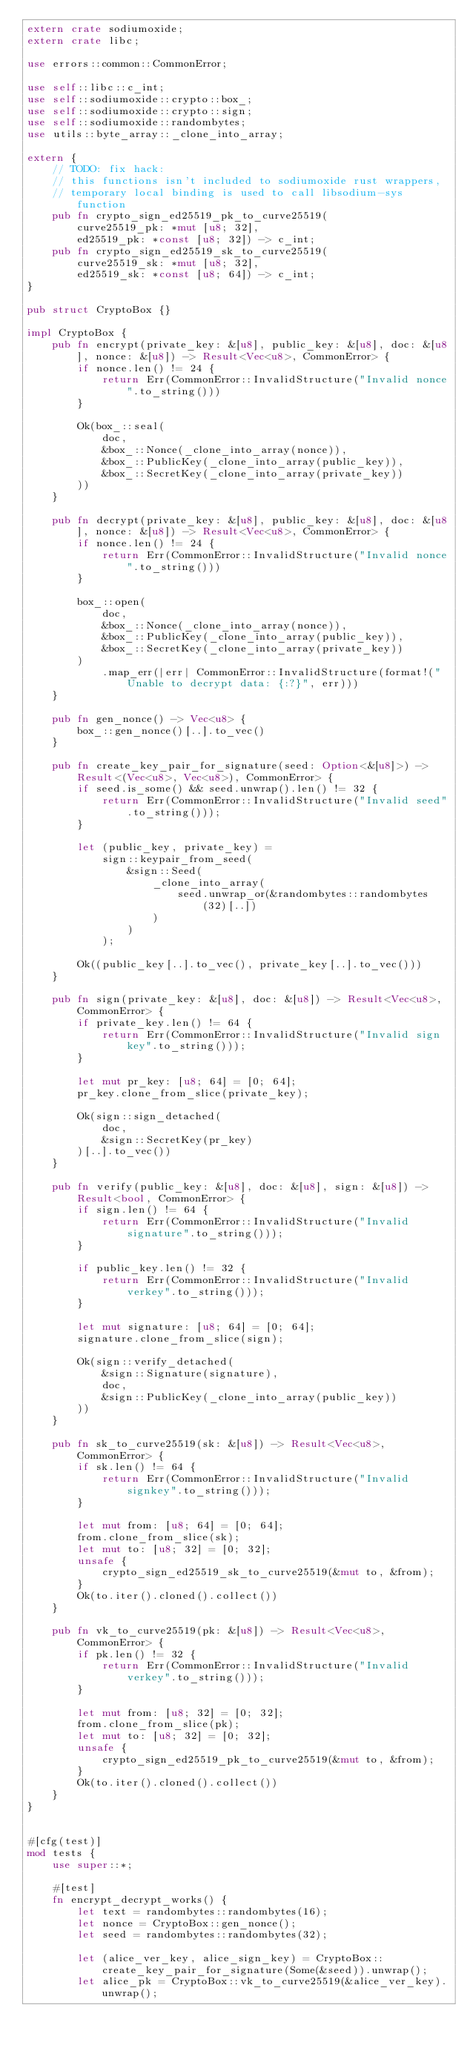<code> <loc_0><loc_0><loc_500><loc_500><_Rust_>extern crate sodiumoxide;
extern crate libc;

use errors::common::CommonError;

use self::libc::c_int;
use self::sodiumoxide::crypto::box_;
use self::sodiumoxide::crypto::sign;
use self::sodiumoxide::randombytes;
use utils::byte_array::_clone_into_array;

extern {
    // TODO: fix hack:
    // this functions isn't included to sodiumoxide rust wrappers,
    // temporary local binding is used to call libsodium-sys function
    pub fn crypto_sign_ed25519_pk_to_curve25519(
        curve25519_pk: *mut [u8; 32],
        ed25519_pk: *const [u8; 32]) -> c_int;
    pub fn crypto_sign_ed25519_sk_to_curve25519(
        curve25519_sk: *mut [u8; 32],
        ed25519_sk: *const [u8; 64]) -> c_int;
}

pub struct CryptoBox {}

impl CryptoBox {
    pub fn encrypt(private_key: &[u8], public_key: &[u8], doc: &[u8], nonce: &[u8]) -> Result<Vec<u8>, CommonError> {
        if nonce.len() != 24 {
            return Err(CommonError::InvalidStructure("Invalid nonce".to_string()))
        }

        Ok(box_::seal(
            doc,
            &box_::Nonce(_clone_into_array(nonce)),
            &box_::PublicKey(_clone_into_array(public_key)),
            &box_::SecretKey(_clone_into_array(private_key))
        ))
    }

    pub fn decrypt(private_key: &[u8], public_key: &[u8], doc: &[u8], nonce: &[u8]) -> Result<Vec<u8>, CommonError> {
        if nonce.len() != 24 {
            return Err(CommonError::InvalidStructure("Invalid nonce".to_string()))
        }

        box_::open(
            doc,
            &box_::Nonce(_clone_into_array(nonce)),
            &box_::PublicKey(_clone_into_array(public_key)),
            &box_::SecretKey(_clone_into_array(private_key))
        )
            .map_err(|err| CommonError::InvalidStructure(format!("Unable to decrypt data: {:?}", err)))
    }

    pub fn gen_nonce() -> Vec<u8> {
        box_::gen_nonce()[..].to_vec()
    }

    pub fn create_key_pair_for_signature(seed: Option<&[u8]>) -> Result<(Vec<u8>, Vec<u8>), CommonError> {
        if seed.is_some() && seed.unwrap().len() != 32 {
            return Err(CommonError::InvalidStructure("Invalid seed".to_string()));
        }

        let (public_key, private_key) =
            sign::keypair_from_seed(
                &sign::Seed(
                    _clone_into_array(
                        seed.unwrap_or(&randombytes::randombytes(32)[..])
                    )
                )
            );

        Ok((public_key[..].to_vec(), private_key[..].to_vec()))
    }

    pub fn sign(private_key: &[u8], doc: &[u8]) -> Result<Vec<u8>, CommonError> {
        if private_key.len() != 64 {
            return Err(CommonError::InvalidStructure("Invalid sign key".to_string()));
        }

        let mut pr_key: [u8; 64] = [0; 64];
        pr_key.clone_from_slice(private_key);

        Ok(sign::sign_detached(
            doc,
            &sign::SecretKey(pr_key)
        )[..].to_vec())
    }

    pub fn verify(public_key: &[u8], doc: &[u8], sign: &[u8]) -> Result<bool, CommonError> {
        if sign.len() != 64 {
            return Err(CommonError::InvalidStructure("Invalid signature".to_string()));
        }

        if public_key.len() != 32 {
            return Err(CommonError::InvalidStructure("Invalid verkey".to_string()));
        }

        let mut signature: [u8; 64] = [0; 64];
        signature.clone_from_slice(sign);

        Ok(sign::verify_detached(
            &sign::Signature(signature),
            doc,
            &sign::PublicKey(_clone_into_array(public_key))
        ))
    }

    pub fn sk_to_curve25519(sk: &[u8]) -> Result<Vec<u8>, CommonError> {
        if sk.len() != 64 {
            return Err(CommonError::InvalidStructure("Invalid signkey".to_string()));
        }

        let mut from: [u8; 64] = [0; 64];
        from.clone_from_slice(sk);
        let mut to: [u8; 32] = [0; 32];
        unsafe {
            crypto_sign_ed25519_sk_to_curve25519(&mut to, &from);
        }
        Ok(to.iter().cloned().collect())
    }

    pub fn vk_to_curve25519(pk: &[u8]) -> Result<Vec<u8>, CommonError> {
        if pk.len() != 32 {
            return Err(CommonError::InvalidStructure("Invalid verkey".to_string()));
        }

        let mut from: [u8; 32] = [0; 32];
        from.clone_from_slice(pk);
        let mut to: [u8; 32] = [0; 32];
        unsafe {
            crypto_sign_ed25519_pk_to_curve25519(&mut to, &from);
        }
        Ok(to.iter().cloned().collect())
    }
}


#[cfg(test)]
mod tests {
    use super::*;

    #[test]
    fn encrypt_decrypt_works() {
        let text = randombytes::randombytes(16);
        let nonce = CryptoBox::gen_nonce();
        let seed = randombytes::randombytes(32);

        let (alice_ver_key, alice_sign_key) = CryptoBox::create_key_pair_for_signature(Some(&seed)).unwrap();
        let alice_pk = CryptoBox::vk_to_curve25519(&alice_ver_key).unwrap();</code> 